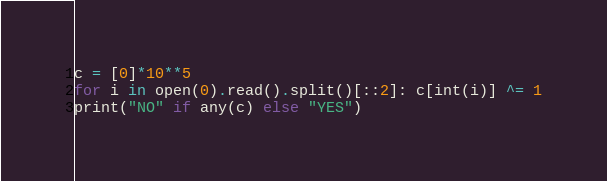Convert code to text. <code><loc_0><loc_0><loc_500><loc_500><_Python_>c = [0]*10**5
for i in open(0).read().split()[::2]: c[int(i)] ^= 1
print("NO" if any(c) else "YES")</code> 